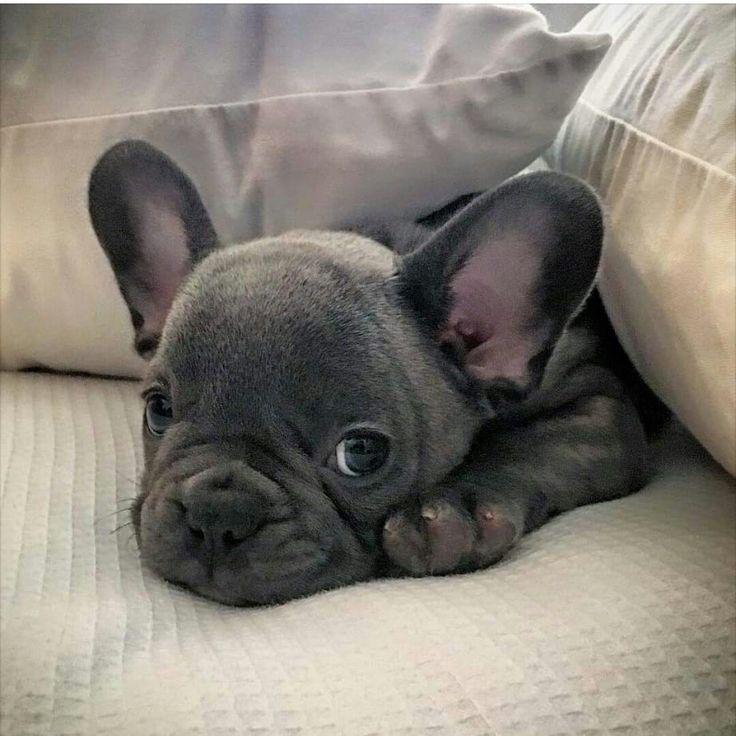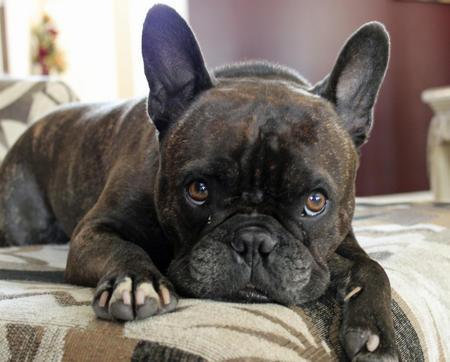The first image is the image on the left, the second image is the image on the right. Examine the images to the left and right. Is the description "All of the dogs are charcoal gray, with at most a patch of white on the chest, and all dogs have blue eyes." accurate? Answer yes or no. No. The first image is the image on the left, the second image is the image on the right. Examine the images to the left and right. Is the description "The dog in the image on the right is outside." accurate? Answer yes or no. No. 